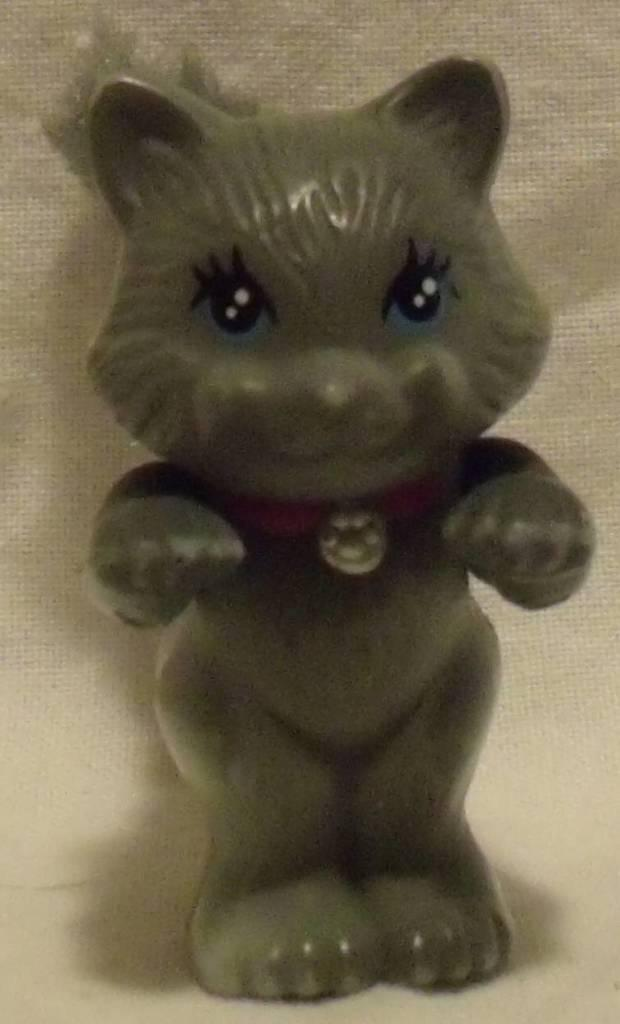What is the main subject of the image? The main subject of the image is a figurine of a cat. Can you describe the position of the cat figurine? The cat figurine is standing. What color is the cat figurine? The cat figurine is green in color. What color is the background of the image? The background of the image is cream in color. Absurd Question/Answer: What message is written on the sign in the image? There is no sign present in the image, so no message can be read. Can you describe the type of spade the cat figurine is holding in the image? There is no spade present in the image; the cat figurine is not holding any object. How does the cat figurine walk in the image? The cat figurine is not walking in the image; it is a stationary figurine. 